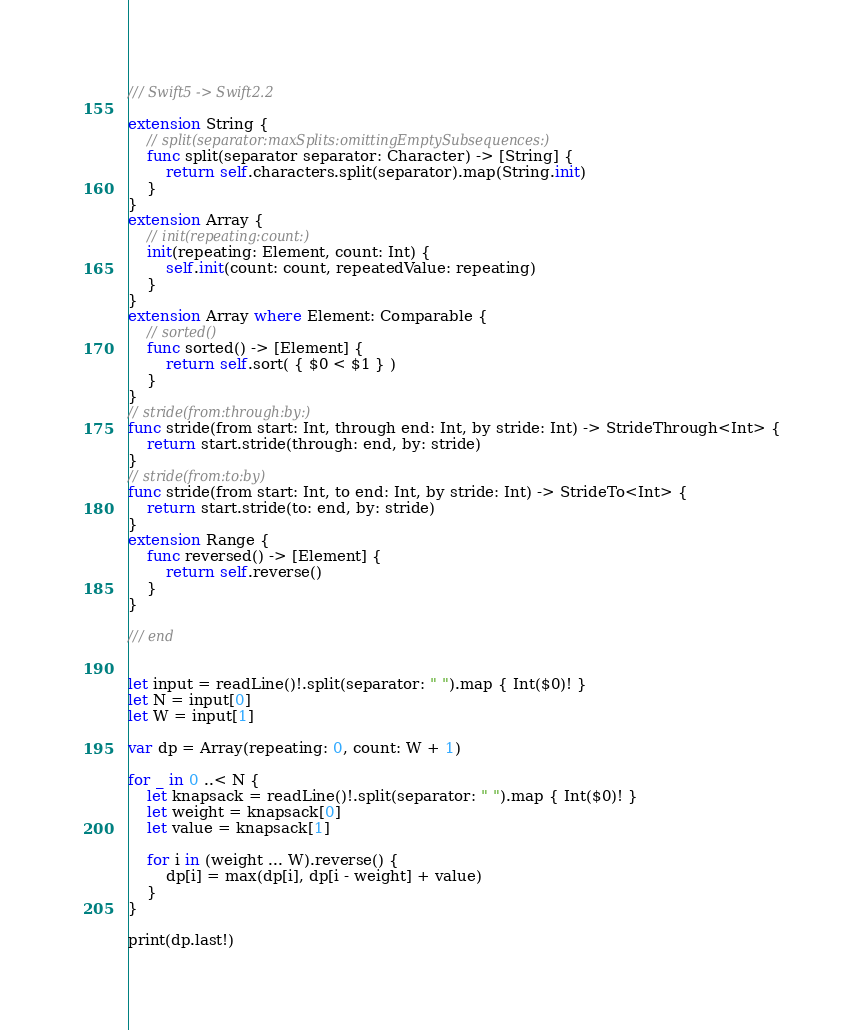<code> <loc_0><loc_0><loc_500><loc_500><_Swift_>/// Swift5 -> Swift2.2

extension String {
    // split(separator:maxSplits:omittingEmptySubsequences:)
    func split(separator separator: Character) -> [String] {
        return self.characters.split(separator).map(String.init)
    }
}
extension Array {
    // init(repeating:count:)
    init(repeating: Element, count: Int) {
        self.init(count: count, repeatedValue: repeating)
    }
}
extension Array where Element: Comparable {
    // sorted()
    func sorted() -> [Element] {
        return self.sort( { $0 < $1 } )
    }
}
// stride(from:through:by:)
func stride(from start: Int, through end: Int, by stride: Int) -> StrideThrough<Int> {
    return start.stride(through: end, by: stride)
}
// stride(from:to:by)
func stride(from start: Int, to end: Int, by stride: Int) -> StrideTo<Int> {
    return start.stride(to: end, by: stride)
}
extension Range {
    func reversed() -> [Element] {
        return self.reverse()
    }
}

/// end


let input = readLine()!.split(separator: " ").map { Int($0)! }
let N = input[0]
let W = input[1]

var dp = Array(repeating: 0, count: W + 1)

for _ in 0 ..< N {
    let knapsack = readLine()!.split(separator: " ").map { Int($0)! }
    let weight = knapsack[0]
    let value = knapsack[1]

    for i in (weight ... W).reverse() {
        dp[i] = max(dp[i], dp[i - weight] + value)
    }
}

print(dp.last!)
</code> 